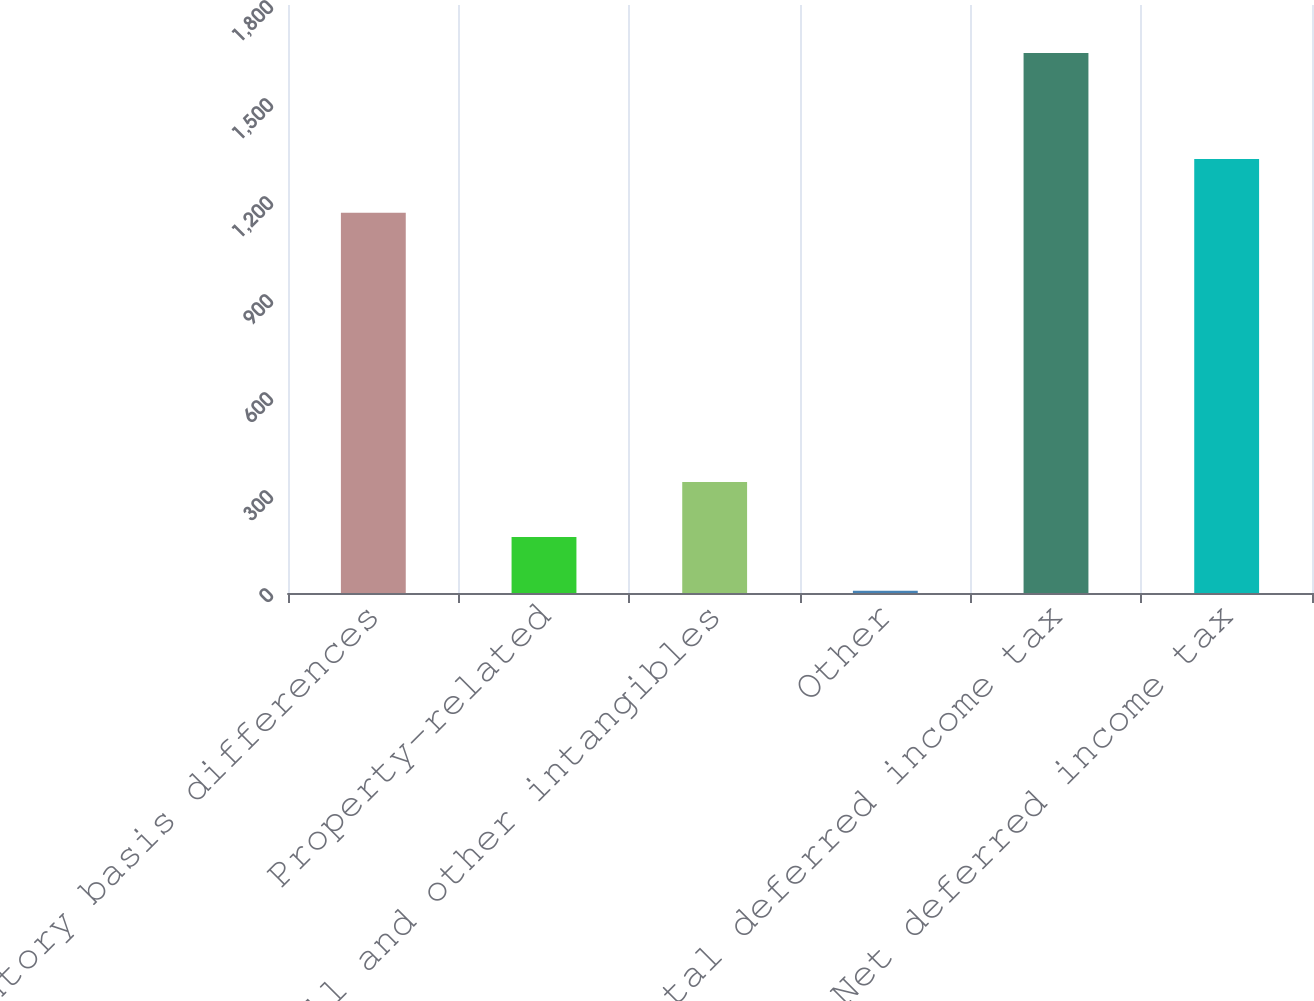Convert chart. <chart><loc_0><loc_0><loc_500><loc_500><bar_chart><fcel>Inventory basis differences<fcel>Property-related<fcel>Goodwill and other intangibles<fcel>Other<fcel>Total deferred income tax<fcel>Net deferred income tax<nl><fcel>1164<fcel>171.6<fcel>340<fcel>7<fcel>1653<fcel>1328.6<nl></chart> 